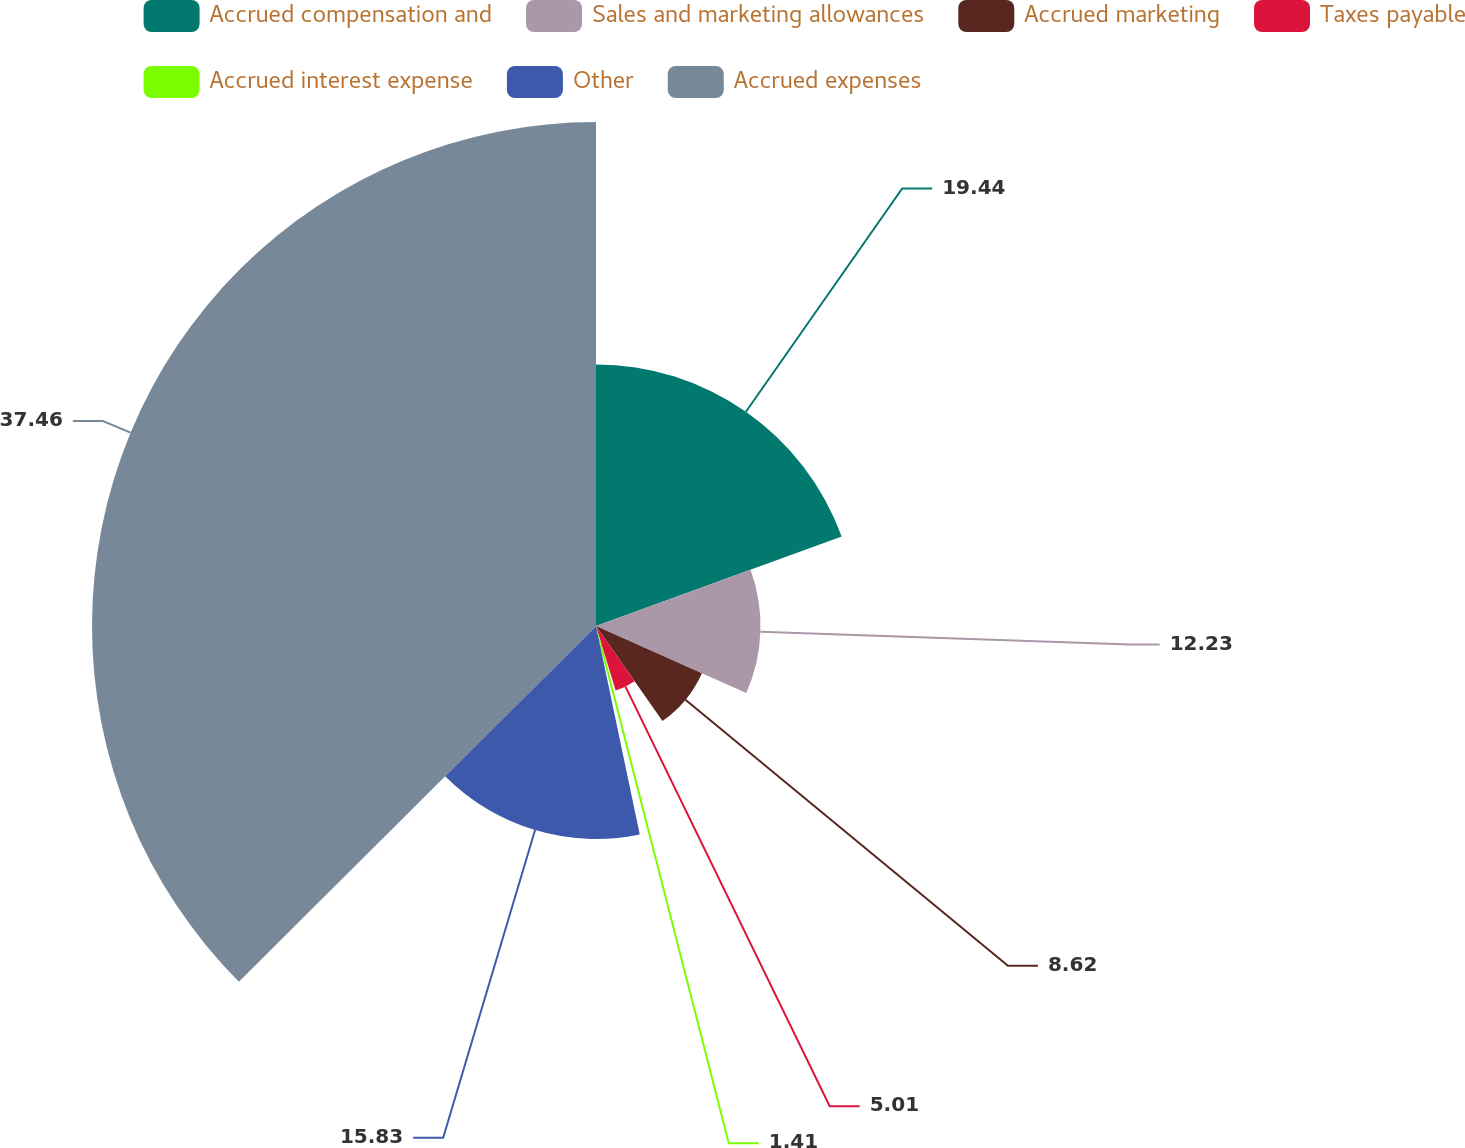<chart> <loc_0><loc_0><loc_500><loc_500><pie_chart><fcel>Accrued compensation and<fcel>Sales and marketing allowances<fcel>Accrued marketing<fcel>Taxes payable<fcel>Accrued interest expense<fcel>Other<fcel>Accrued expenses<nl><fcel>19.44%<fcel>12.23%<fcel>8.62%<fcel>5.01%<fcel>1.41%<fcel>15.83%<fcel>37.47%<nl></chart> 